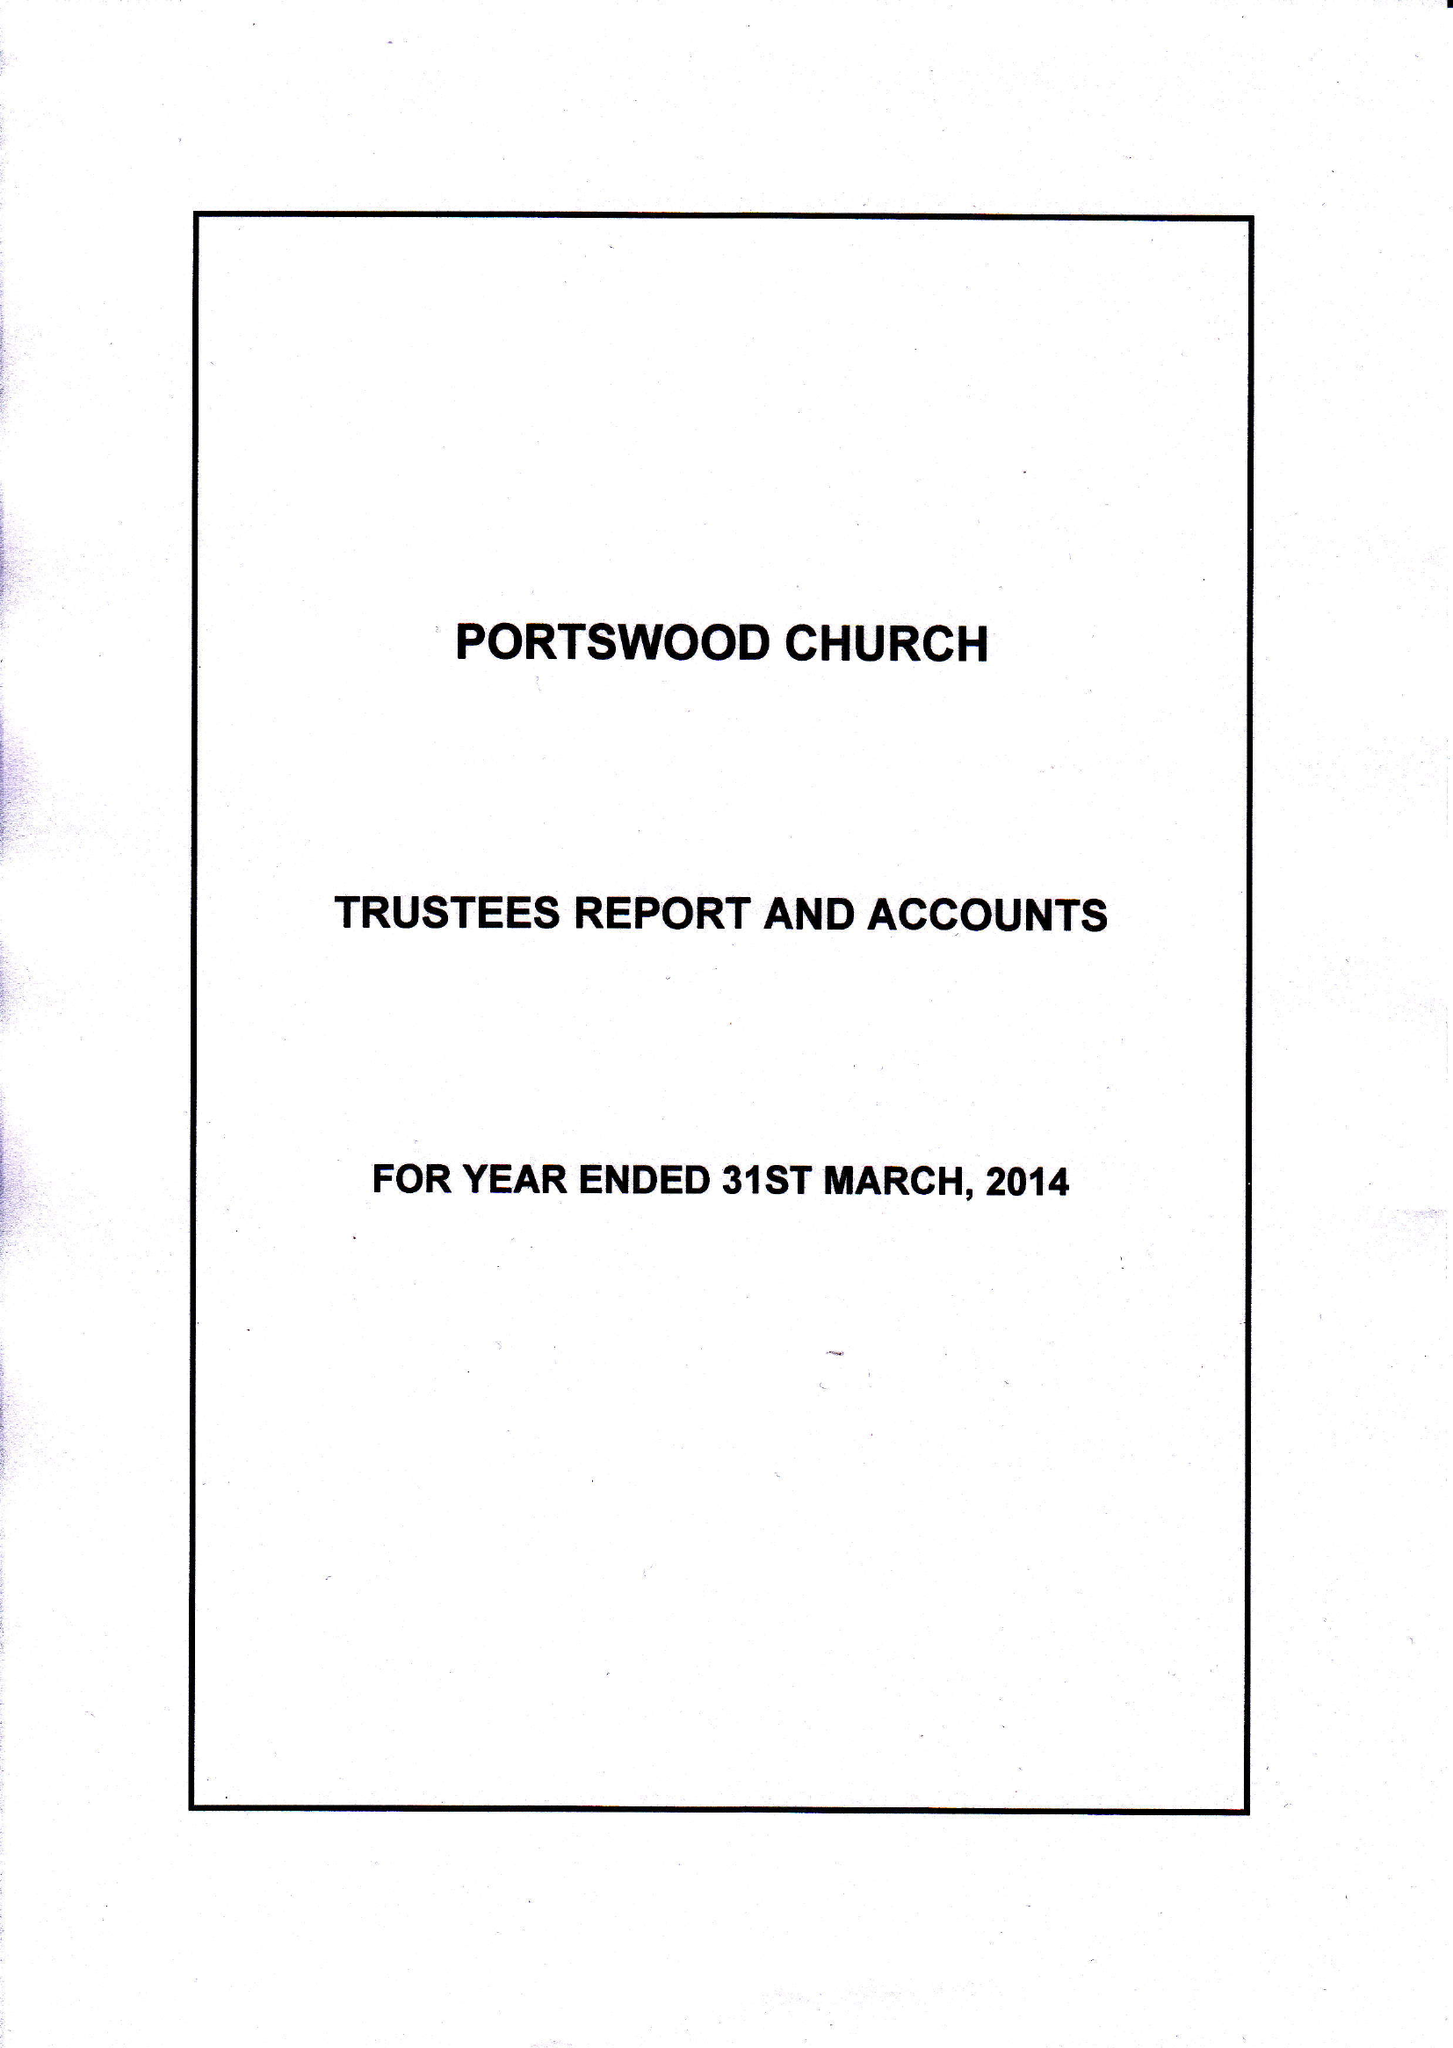What is the value for the charity_name?
Answer the question using a single word or phrase. Portswood Church 